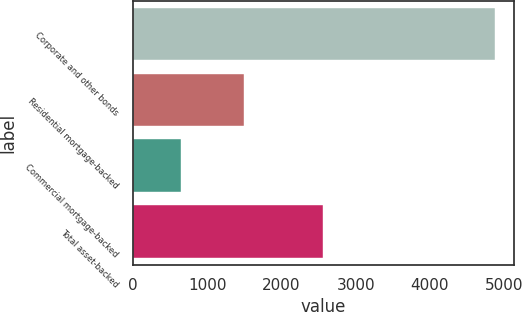<chart> <loc_0><loc_0><loc_500><loc_500><bar_chart><fcel>Corporate and other bonds<fcel>Residential mortgage-backed<fcel>Commercial mortgage-backed<fcel>Total asset-backed<nl><fcel>4882<fcel>1498<fcel>652<fcel>2559<nl></chart> 